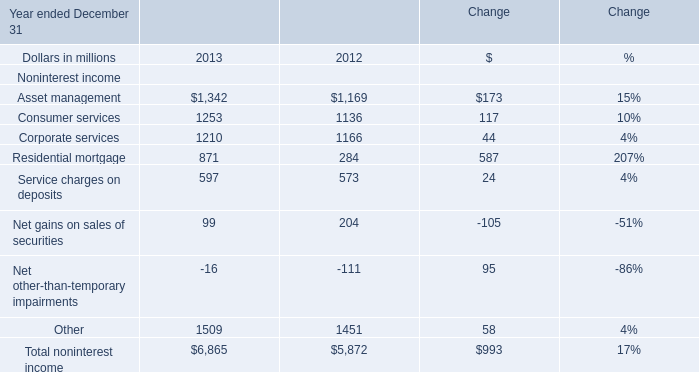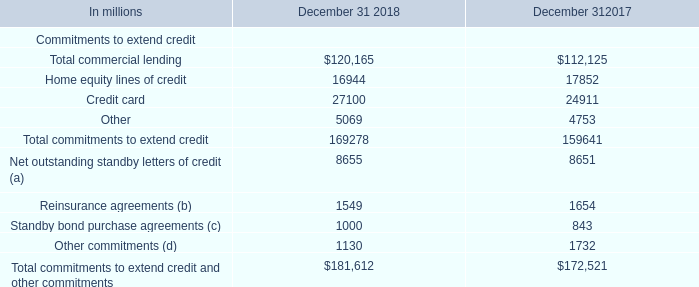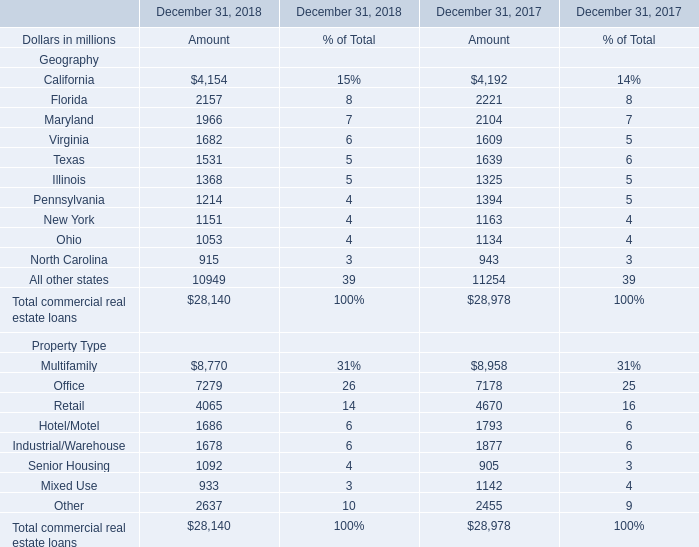What was the average value of New York, Ohio, North Carolina in 2018 ? (in million) 
Computations: (((1151 + 1053) + 915) / 3)
Answer: 1039.66667. What is the sum of Texas of Amount in 2017 and Corporate services in 2012? (in million) 
Computations: (1639 + 1166)
Answer: 2805.0. 